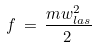<formula> <loc_0><loc_0><loc_500><loc_500>f \, = \, \frac { m w _ { l a s } ^ { 2 } } { 2 \, }</formula> 